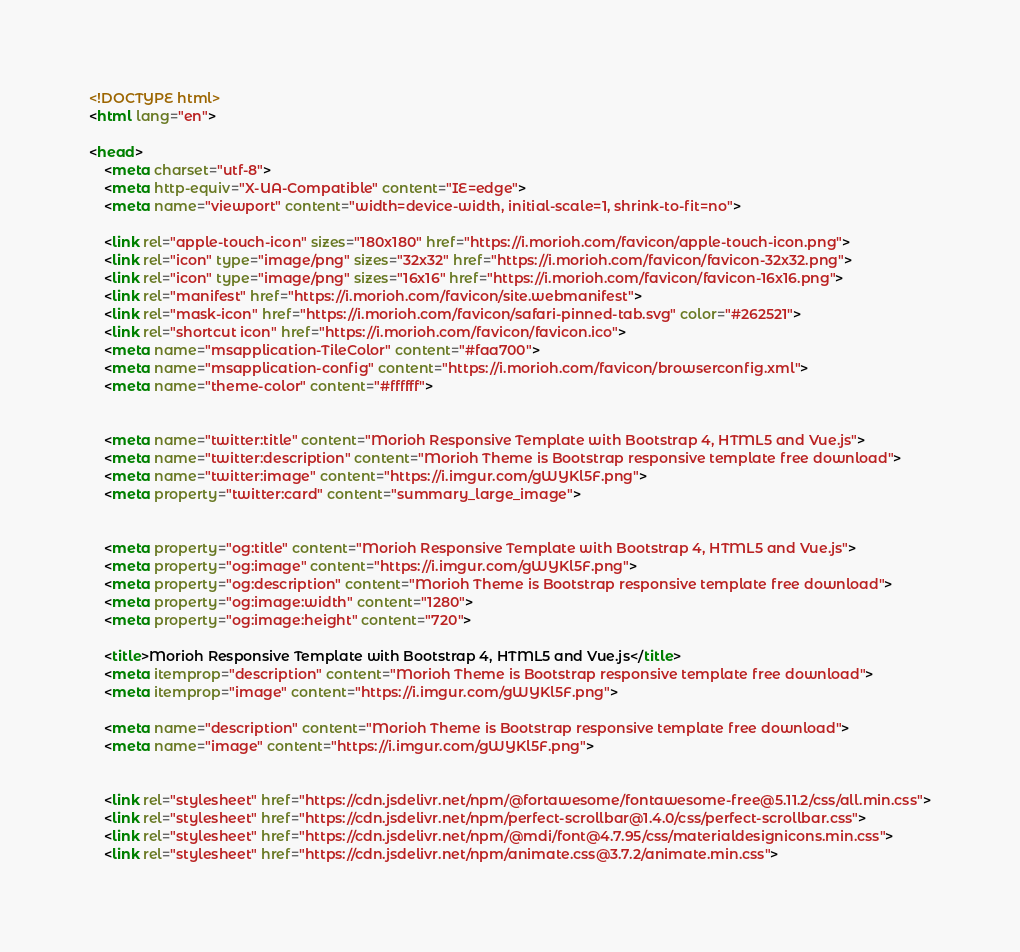Convert code to text. <code><loc_0><loc_0><loc_500><loc_500><_HTML_><!DOCTYPE html>
<html lang="en">

<head>
    <meta charset="utf-8">
    <meta http-equiv="X-UA-Compatible" content="IE=edge">
    <meta name="viewport" content="width=device-width, initial-scale=1, shrink-to-fit=no">

    <link rel="apple-touch-icon" sizes="180x180" href="https://i.morioh.com/favicon/apple-touch-icon.png">
    <link rel="icon" type="image/png" sizes="32x32" href="https://i.morioh.com/favicon/favicon-32x32.png">
    <link rel="icon" type="image/png" sizes="16x16" href="https://i.morioh.com/favicon/favicon-16x16.png">
    <link rel="manifest" href="https://i.morioh.com/favicon/site.webmanifest">
    <link rel="mask-icon" href="https://i.morioh.com/favicon/safari-pinned-tab.svg" color="#262521">
    <link rel="shortcut icon" href="https://i.morioh.com/favicon/favicon.ico">
    <meta name="msapplication-TileColor" content="#faa700">
    <meta name="msapplication-config" content="https://i.morioh.com/favicon/browserconfig.xml">
    <meta name="theme-color" content="#ffffff">


    <meta name="twitter:title" content="Morioh Responsive Template with Bootstrap 4, HTML5 and Vue.js">
    <meta name="twitter:description" content="Morioh Theme is Bootstrap responsive template free download">
    <meta name="twitter:image" content="https://i.imgur.com/gWYKl5F.png">
    <meta property="twitter:card" content="summary_large_image">


    <meta property="og:title" content="Morioh Responsive Template with Bootstrap 4, HTML5 and Vue.js">
    <meta property="og:image" content="https://i.imgur.com/gWYKl5F.png">
    <meta property="og:description" content="Morioh Theme is Bootstrap responsive template free download">
    <meta property="og:image:width" content="1280">
    <meta property="og:image:height" content="720">

    <title>Morioh Responsive Template with Bootstrap 4, HTML5 and Vue.js</title>
    <meta itemprop="description" content="Morioh Theme is Bootstrap responsive template free download">
    <meta itemprop="image" content="https://i.imgur.com/gWYKl5F.png">

    <meta name="description" content="Morioh Theme is Bootstrap responsive template free download">
    <meta name="image" content="https://i.imgur.com/gWYKl5F.png">


    <link rel="stylesheet" href="https://cdn.jsdelivr.net/npm/@fortawesome/fontawesome-free@5.11.2/css/all.min.css">
    <link rel="stylesheet" href="https://cdn.jsdelivr.net/npm/perfect-scrollbar@1.4.0/css/perfect-scrollbar.css">
    <link rel="stylesheet" href="https://cdn.jsdelivr.net/npm/@mdi/font@4.7.95/css/materialdesignicons.min.css">
    <link rel="stylesheet" href="https://cdn.jsdelivr.net/npm/animate.css@3.7.2/animate.min.css">
</code> 